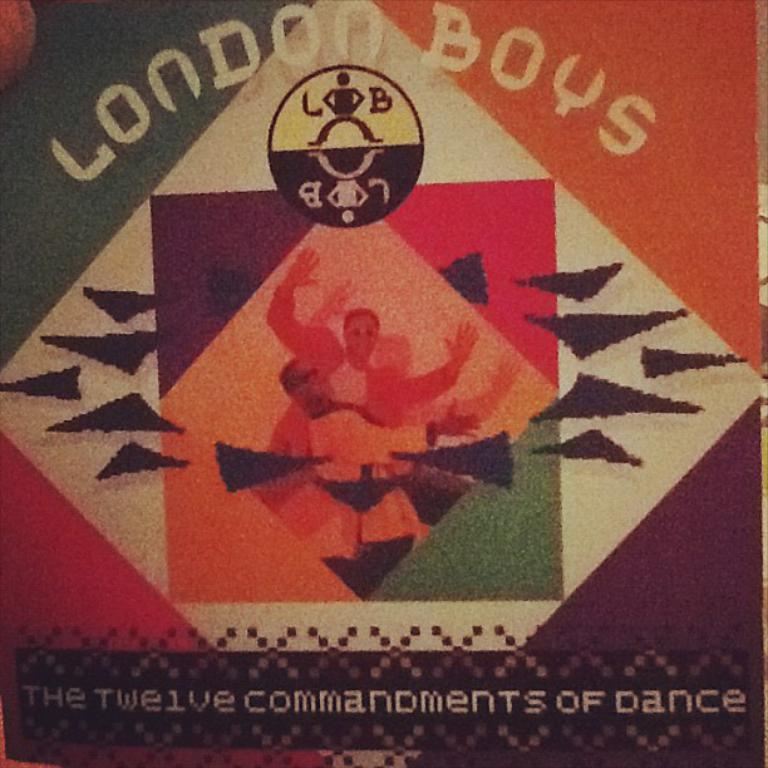<image>
Render a clear and concise summary of the photo. A flyer advertises London Boys, a dance group. 